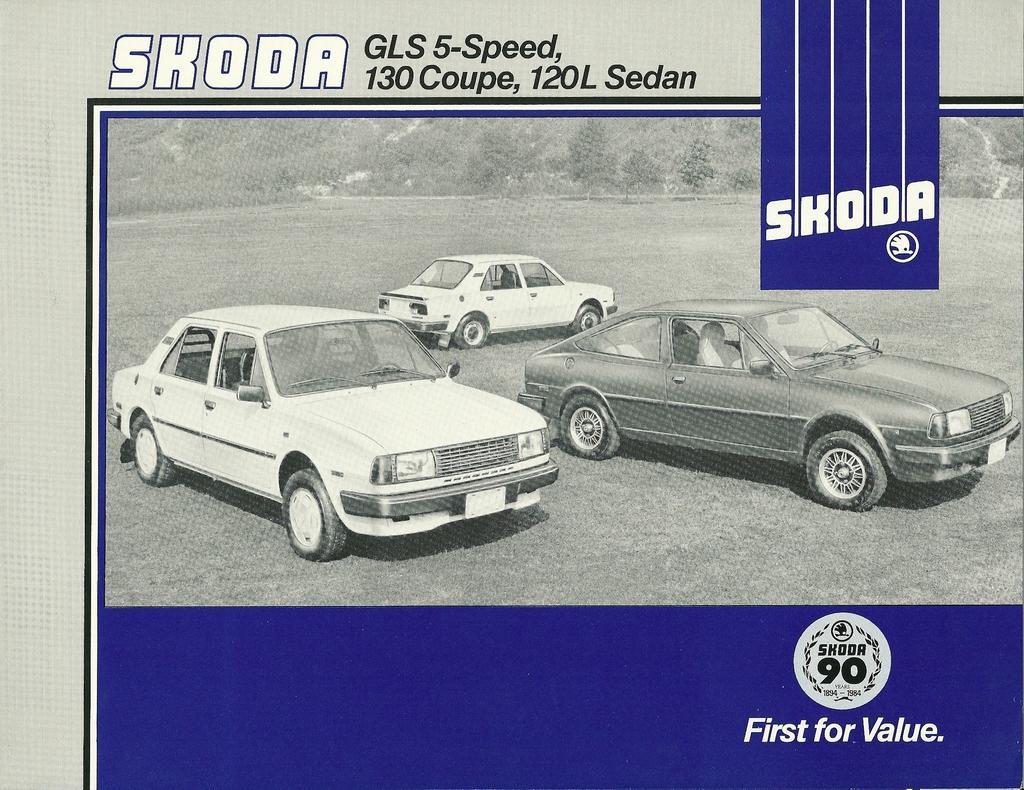Could you give a brief overview of what you see in this image? In the picture we can see pamphlet with three car images on the surface and on the top of it we can see the same as SKODA. 